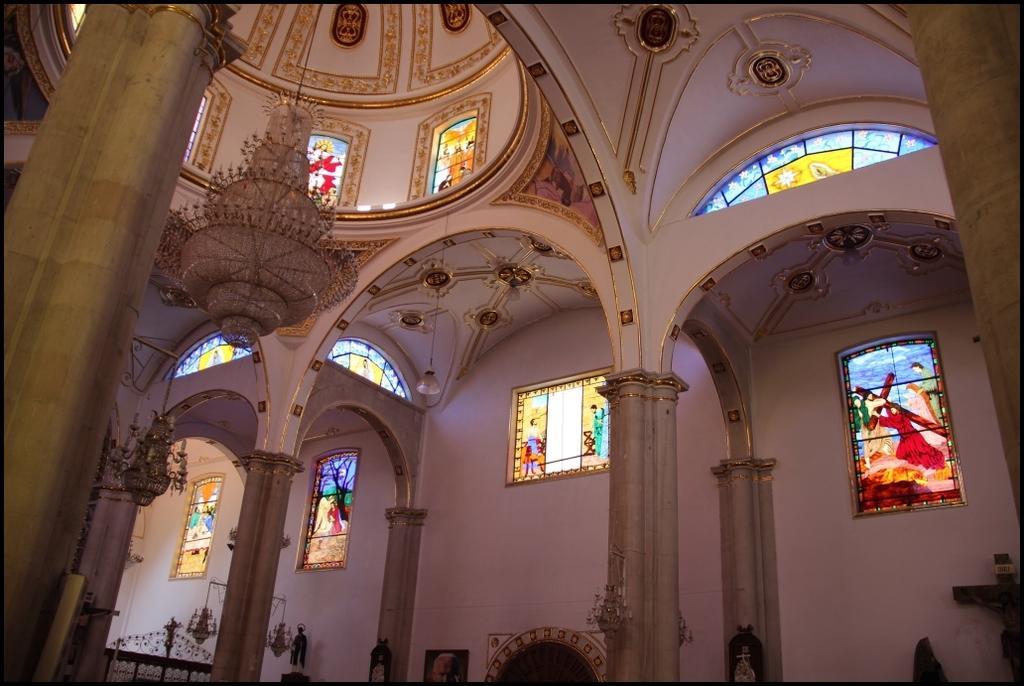Can you describe this image briefly? In this picture we can see an inside view of a building, there are stained glasses here, we can see a chandelier here, in the background there is a wall, we can see pillars here. 